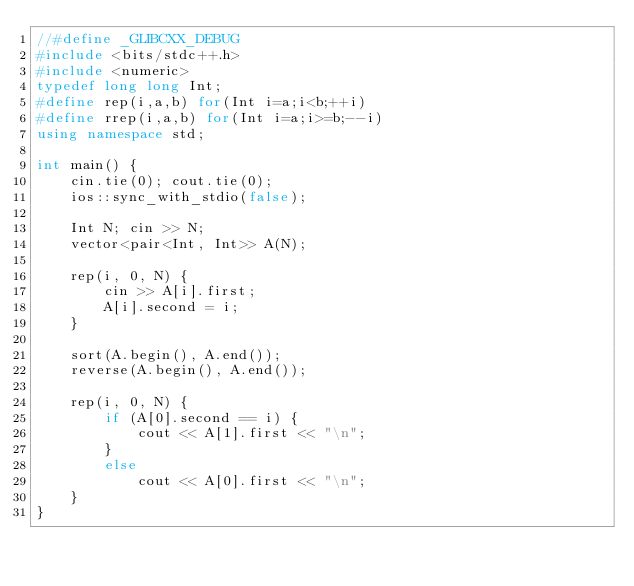Convert code to text. <code><loc_0><loc_0><loc_500><loc_500><_C++_>//#define _GLIBCXX_DEBUG
#include <bits/stdc++.h>
#include <numeric>
typedef long long Int;
#define rep(i,a,b) for(Int i=a;i<b;++i)
#define rrep(i,a,b) for(Int i=a;i>=b;--i)
using namespace std;

int main() {
    cin.tie(0); cout.tie(0);
    ios::sync_with_stdio(false);

    Int N; cin >> N;
    vector<pair<Int, Int>> A(N);

    rep(i, 0, N) {
        cin >> A[i].first;
        A[i].second = i;
    }

    sort(A.begin(), A.end());
    reverse(A.begin(), A.end());

    rep(i, 0, N) {
        if (A[0].second == i) {
            cout << A[1].first << "\n";
        }
        else
            cout << A[0].first << "\n";
    }
}
</code> 